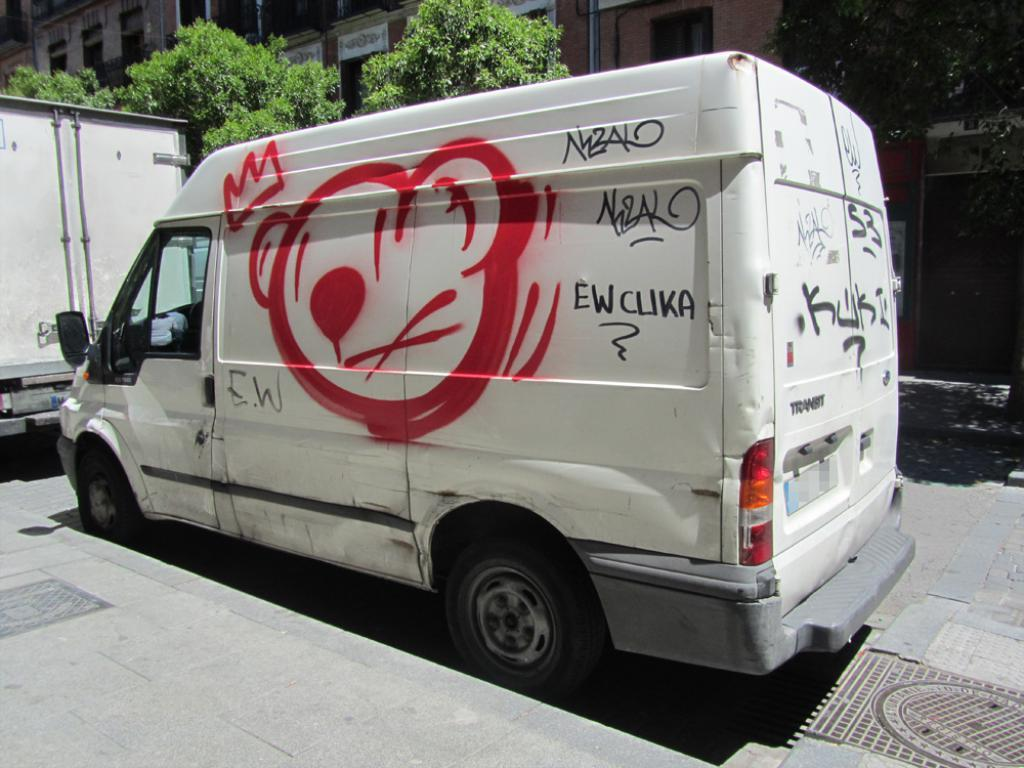What can be seen on the road in the image? There are vehicles on the road in the image. What type of natural elements can be seen in the background of the image? Trees are visible in the background of the image. What type of man-made structures can be seen in the background of the image? There are buildings in the background of the image. Can you see a cow grazing on the wire in the image? There is no cow or wire present in the image. What type of wind can be seen blowing through the trees in the image? There is no wind visible in the image, and the type of wind cannot be determined from the image. 